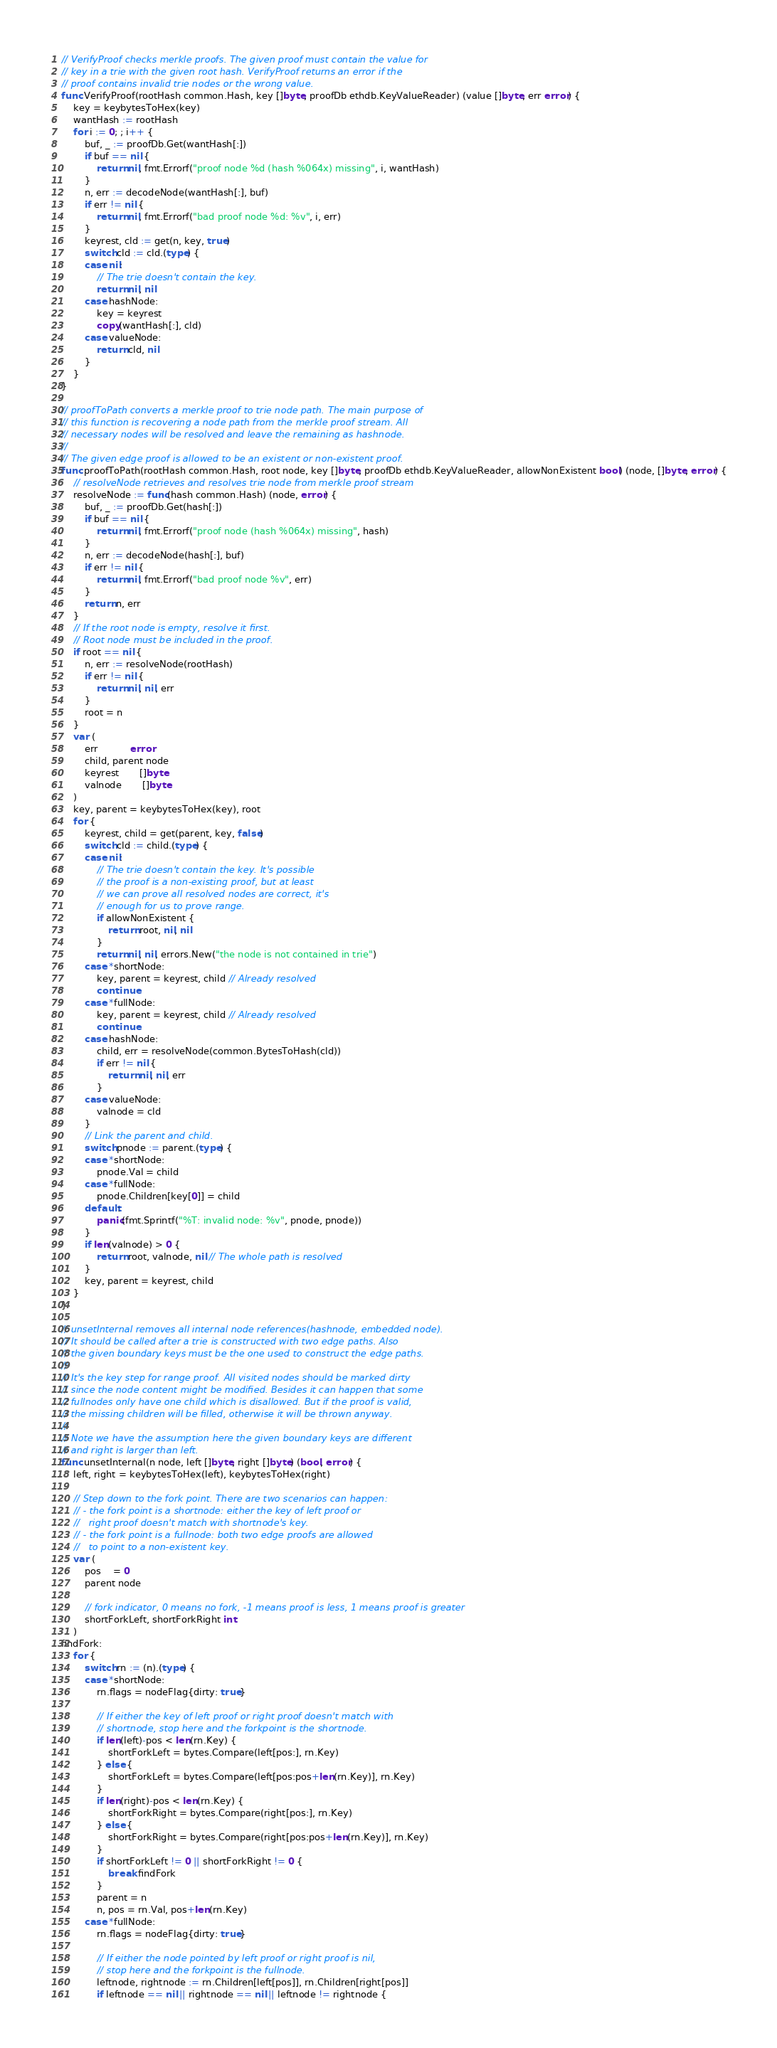<code> <loc_0><loc_0><loc_500><loc_500><_Go_>
// VerifyProof checks merkle proofs. The given proof must contain the value for
// key in a trie with the given root hash. VerifyProof returns an error if the
// proof contains invalid trie nodes or the wrong value.
func VerifyProof(rootHash common.Hash, key []byte, proofDb ethdb.KeyValueReader) (value []byte, err error) {
	key = keybytesToHex(key)
	wantHash := rootHash
	for i := 0; ; i++ {
		buf, _ := proofDb.Get(wantHash[:])
		if buf == nil {
			return nil, fmt.Errorf("proof node %d (hash %064x) missing", i, wantHash)
		}
		n, err := decodeNode(wantHash[:], buf)
		if err != nil {
			return nil, fmt.Errorf("bad proof node %d: %v", i, err)
		}
		keyrest, cld := get(n, key, true)
		switch cld := cld.(type) {
		case nil:
			// The trie doesn't contain the key.
			return nil, nil
		case hashNode:
			key = keyrest
			copy(wantHash[:], cld)
		case valueNode:
			return cld, nil
		}
	}
}

// proofToPath converts a merkle proof to trie node path. The main purpose of
// this function is recovering a node path from the merkle proof stream. All
// necessary nodes will be resolved and leave the remaining as hashnode.
//
// The given edge proof is allowed to be an existent or non-existent proof.
func proofToPath(rootHash common.Hash, root node, key []byte, proofDb ethdb.KeyValueReader, allowNonExistent bool) (node, []byte, error) {
	// resolveNode retrieves and resolves trie node from merkle proof stream
	resolveNode := func(hash common.Hash) (node, error) {
		buf, _ := proofDb.Get(hash[:])
		if buf == nil {
			return nil, fmt.Errorf("proof node (hash %064x) missing", hash)
		}
		n, err := decodeNode(hash[:], buf)
		if err != nil {
			return nil, fmt.Errorf("bad proof node %v", err)
		}
		return n, err
	}
	// If the root node is empty, resolve it first.
	// Root node must be included in the proof.
	if root == nil {
		n, err := resolveNode(rootHash)
		if err != nil {
			return nil, nil, err
		}
		root = n
	}
	var (
		err           error
		child, parent node
		keyrest       []byte
		valnode       []byte
	)
	key, parent = keybytesToHex(key), root
	for {
		keyrest, child = get(parent, key, false)
		switch cld := child.(type) {
		case nil:
			// The trie doesn't contain the key. It's possible
			// the proof is a non-existing proof, but at least
			// we can prove all resolved nodes are correct, it's
			// enough for us to prove range.
			if allowNonExistent {
				return root, nil, nil
			}
			return nil, nil, errors.New("the node is not contained in trie")
		case *shortNode:
			key, parent = keyrest, child // Already resolved
			continue
		case *fullNode:
			key, parent = keyrest, child // Already resolved
			continue
		case hashNode:
			child, err = resolveNode(common.BytesToHash(cld))
			if err != nil {
				return nil, nil, err
			}
		case valueNode:
			valnode = cld
		}
		// Link the parent and child.
		switch pnode := parent.(type) {
		case *shortNode:
			pnode.Val = child
		case *fullNode:
			pnode.Children[key[0]] = child
		default:
			panic(fmt.Sprintf("%T: invalid node: %v", pnode, pnode))
		}
		if len(valnode) > 0 {
			return root, valnode, nil // The whole path is resolved
		}
		key, parent = keyrest, child
	}
}

// unsetInternal removes all internal node references(hashnode, embedded node).
// It should be called after a trie is constructed with two edge paths. Also
// the given boundary keys must be the one used to construct the edge paths.
//
// It's the key step for range proof. All visited nodes should be marked dirty
// since the node content might be modified. Besides it can happen that some
// fullnodes only have one child which is disallowed. But if the proof is valid,
// the missing children will be filled, otherwise it will be thrown anyway.
//
// Note we have the assumption here the given boundary keys are different
// and right is larger than left.
func unsetInternal(n node, left []byte, right []byte) (bool, error) {
	left, right = keybytesToHex(left), keybytesToHex(right)

	// Step down to the fork point. There are two scenarios can happen:
	// - the fork point is a shortnode: either the key of left proof or
	//   right proof doesn't match with shortnode's key.
	// - the fork point is a fullnode: both two edge proofs are allowed
	//   to point to a non-existent key.
	var (
		pos    = 0
		parent node

		// fork indicator, 0 means no fork, -1 means proof is less, 1 means proof is greater
		shortForkLeft, shortForkRight int
	)
findFork:
	for {
		switch rn := (n).(type) {
		case *shortNode:
			rn.flags = nodeFlag{dirty: true}

			// If either the key of left proof or right proof doesn't match with
			// shortnode, stop here and the forkpoint is the shortnode.
			if len(left)-pos < len(rn.Key) {
				shortForkLeft = bytes.Compare(left[pos:], rn.Key)
			} else {
				shortForkLeft = bytes.Compare(left[pos:pos+len(rn.Key)], rn.Key)
			}
			if len(right)-pos < len(rn.Key) {
				shortForkRight = bytes.Compare(right[pos:], rn.Key)
			} else {
				shortForkRight = bytes.Compare(right[pos:pos+len(rn.Key)], rn.Key)
			}
			if shortForkLeft != 0 || shortForkRight != 0 {
				break findFork
			}
			parent = n
			n, pos = rn.Val, pos+len(rn.Key)
		case *fullNode:
			rn.flags = nodeFlag{dirty: true}

			// If either the node pointed by left proof or right proof is nil,
			// stop here and the forkpoint is the fullnode.
			leftnode, rightnode := rn.Children[left[pos]], rn.Children[right[pos]]
			if leftnode == nil || rightnode == nil || leftnode != rightnode {</code> 